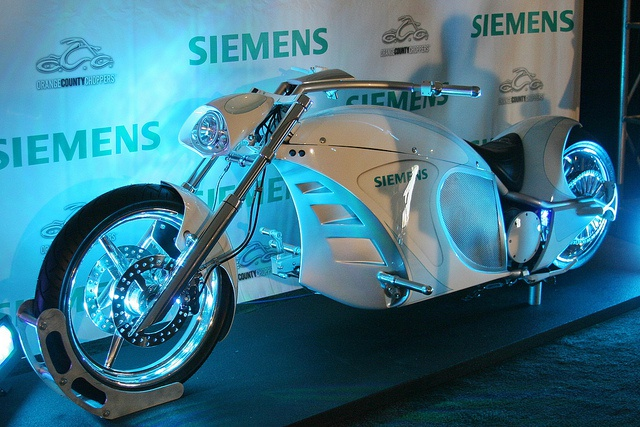Describe the objects in this image and their specific colors. I can see a motorcycle in gray, black, and lightblue tones in this image. 